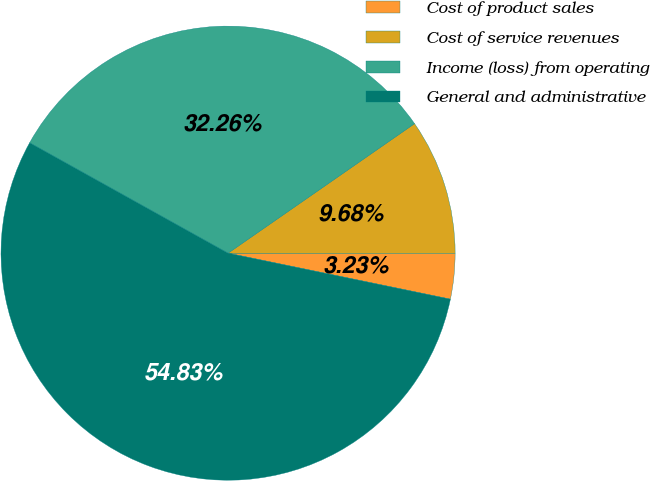Convert chart. <chart><loc_0><loc_0><loc_500><loc_500><pie_chart><fcel>Cost of product sales<fcel>Cost of service revenues<fcel>Income (loss) from operating<fcel>General and administrative<nl><fcel>3.23%<fcel>9.68%<fcel>32.26%<fcel>54.84%<nl></chart> 